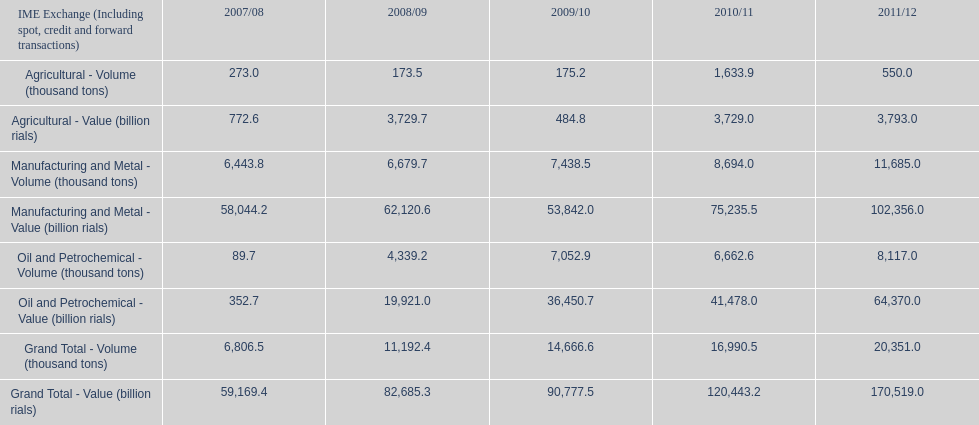How many consecutive year did the grand total value grow in iran? 4. 